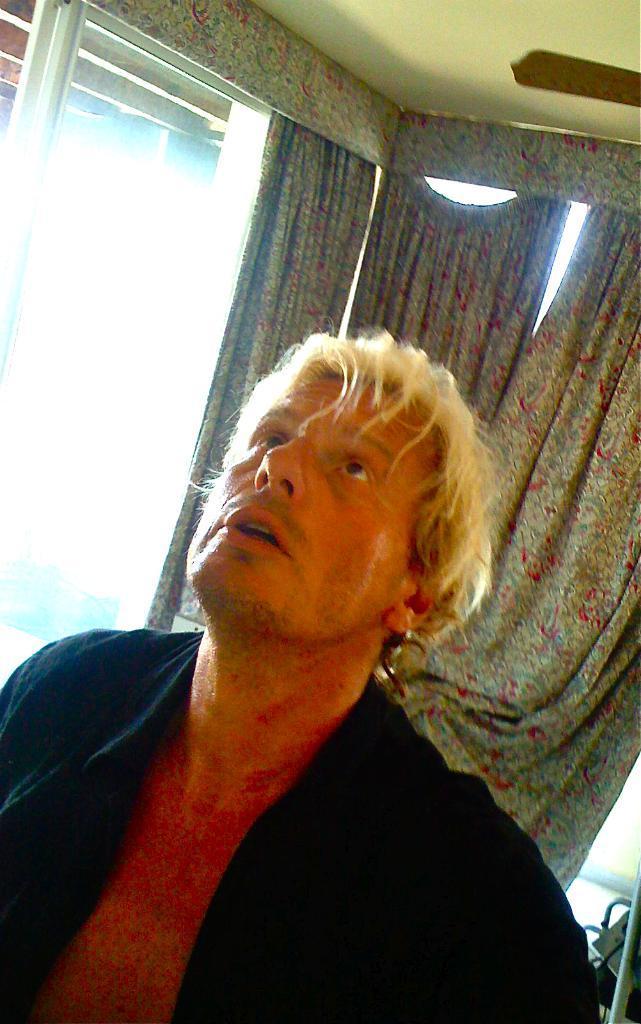How would you summarize this image in a sentence or two? In the picture I can see a person in the left corner is wearing black dress and there is a glass window and curtains in the background. 